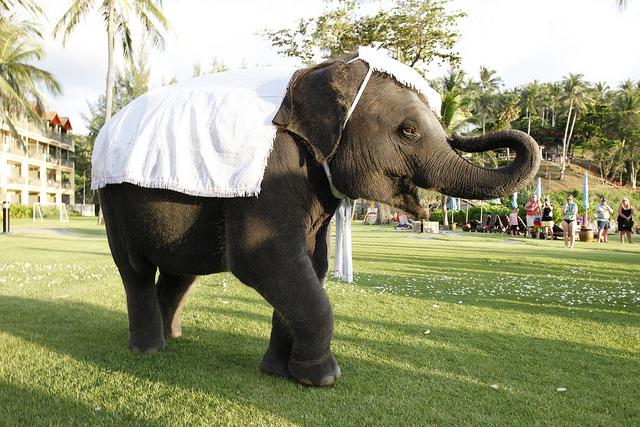Is the elephants trunk up or down?
Keep it brief. Up. What trees are predominant in this picture?
Short answer required. Palm. What is the animal wearing?
Quick response, please. Blanket. What kind of blanket is on the elephants back?
Keep it brief. White. What's on the elephant's butt?
Write a very short answer. Blanket. Which knee is the elephant lifting?
Keep it brief. Right. 